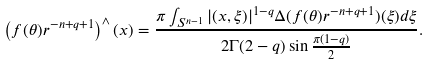<formula> <loc_0><loc_0><loc_500><loc_500>\left ( f ( \theta ) r ^ { - n + q + 1 } \right ) ^ { \wedge } ( x ) = \frac { \pi \int _ { S ^ { n - 1 } } | ( x , \xi ) | ^ { 1 - q } \Delta ( f ( \theta ) r ^ { - n + q + 1 } ) ( \xi ) d \xi } { 2 \Gamma ( 2 - q ) \sin \frac { \pi ( 1 - q ) } { 2 } } .</formula> 